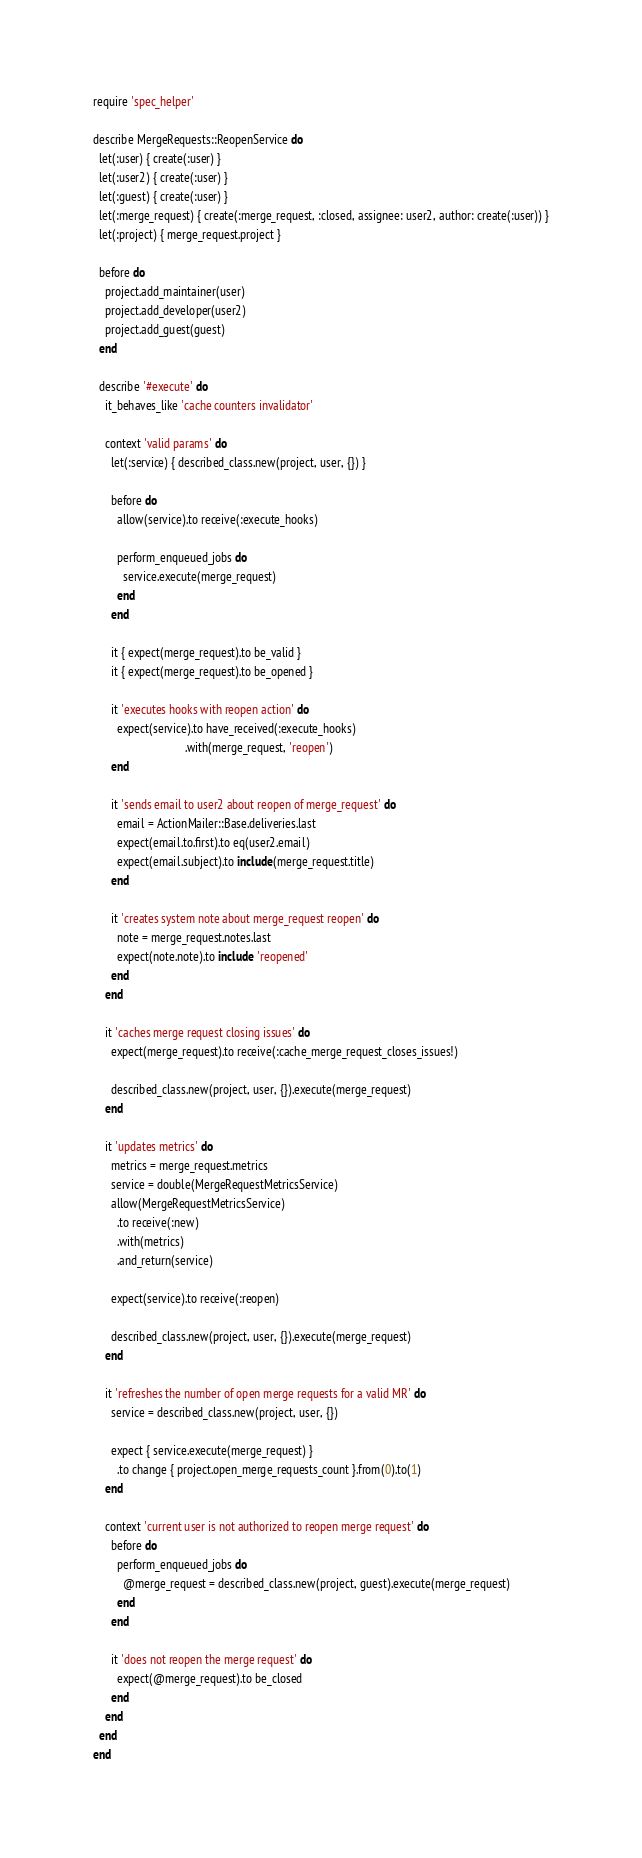<code> <loc_0><loc_0><loc_500><loc_500><_Ruby_>require 'spec_helper'

describe MergeRequests::ReopenService do
  let(:user) { create(:user) }
  let(:user2) { create(:user) }
  let(:guest) { create(:user) }
  let(:merge_request) { create(:merge_request, :closed, assignee: user2, author: create(:user)) }
  let(:project) { merge_request.project }

  before do
    project.add_maintainer(user)
    project.add_developer(user2)
    project.add_guest(guest)
  end

  describe '#execute' do
    it_behaves_like 'cache counters invalidator'

    context 'valid params' do
      let(:service) { described_class.new(project, user, {}) }

      before do
        allow(service).to receive(:execute_hooks)

        perform_enqueued_jobs do
          service.execute(merge_request)
        end
      end

      it { expect(merge_request).to be_valid }
      it { expect(merge_request).to be_opened }

      it 'executes hooks with reopen action' do
        expect(service).to have_received(:execute_hooks)
                               .with(merge_request, 'reopen')
      end

      it 'sends email to user2 about reopen of merge_request' do
        email = ActionMailer::Base.deliveries.last
        expect(email.to.first).to eq(user2.email)
        expect(email.subject).to include(merge_request.title)
      end

      it 'creates system note about merge_request reopen' do
        note = merge_request.notes.last
        expect(note.note).to include 'reopened'
      end
    end

    it 'caches merge request closing issues' do
      expect(merge_request).to receive(:cache_merge_request_closes_issues!)

      described_class.new(project, user, {}).execute(merge_request)
    end

    it 'updates metrics' do
      metrics = merge_request.metrics
      service = double(MergeRequestMetricsService)
      allow(MergeRequestMetricsService)
        .to receive(:new)
        .with(metrics)
        .and_return(service)

      expect(service).to receive(:reopen)

      described_class.new(project, user, {}).execute(merge_request)
    end

    it 'refreshes the number of open merge requests for a valid MR' do
      service = described_class.new(project, user, {})

      expect { service.execute(merge_request) }
        .to change { project.open_merge_requests_count }.from(0).to(1)
    end

    context 'current user is not authorized to reopen merge request' do
      before do
        perform_enqueued_jobs do
          @merge_request = described_class.new(project, guest).execute(merge_request)
        end
      end

      it 'does not reopen the merge request' do
        expect(@merge_request).to be_closed
      end
    end
  end
end
</code> 